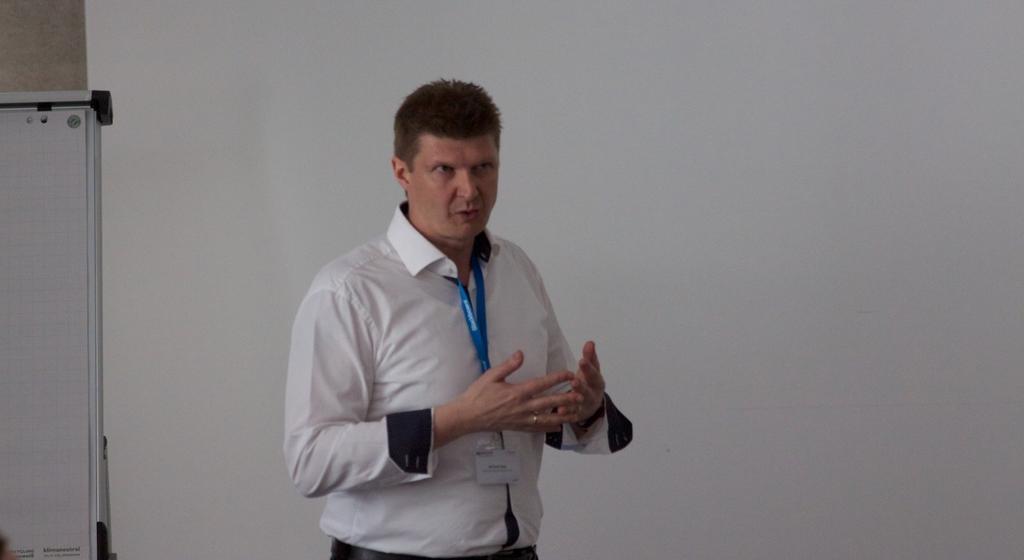In one or two sentences, can you explain what this image depicts? In this image there is a man standing wearing a tag, behind him there is a board. 